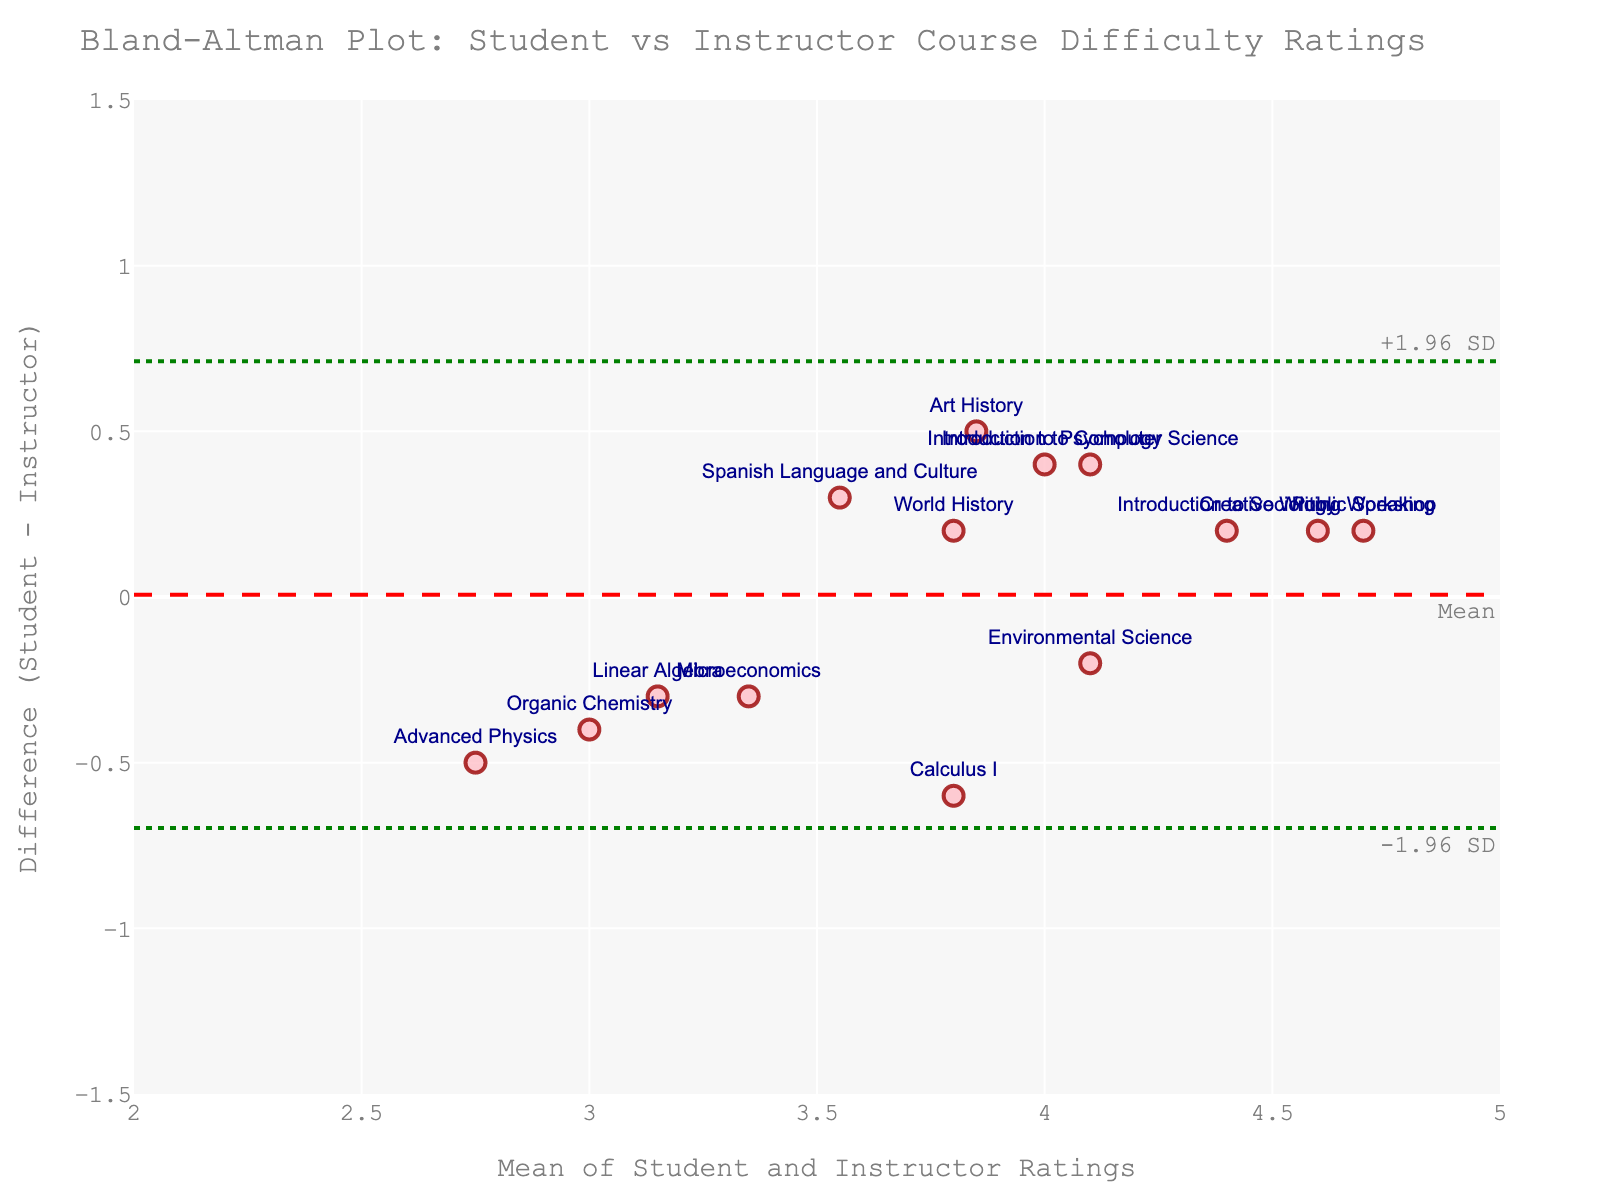What's the title of the plot? The plot has a clear title at the top which helps to identify what the data represents. Reading the header information, the title says "Bland-Altman Plot: Student vs Instructor Course Difficulty Ratings". This succinctly describes the focus of the analysis.
Answer: Bland-Altman Plot: Student vs Instructor Course Difficulty Ratings How many courses have been evaluated? By counting the number of markers representing the courses on the scatter plot, you can determine the number of evaluations included. There are 14 markers, each labeled with a course name.
Answer: 14 What do the x and y axes represent? The x-axis and the y-axis labels provide information about what is being plotted. The x-axis is labeled as "Mean of Student and Instructor Ratings", and the y-axis is labeled as "Difference (Student - Instructor)". These labels indicate the values being compared on each axis.
Answer: x-axis: Mean of Student and Instructor Ratings; y-axis: Difference (Student - Instructor) What is the overall mean difference in ratings between students and instructors? This can be found by looking at the dashed horizontal line labeled "Mean". It represents the average difference between student and instructor ratings. The mean difference is found at a particular point on the y-axis, which appears to be around 0.
Answer: Around 0 What are the limits of agreement? The horizontal dotted lines represent the limits of agreement. These are typically calculated as mean difference ± 1.96 times the standard deviation of the differences. Observing the dotted lines, one is labeled as "-1.96 SD" and another as "+1.96 SD". The values are found at approximately -0.8 and 0.8.
Answer: -0.8 and 0.8 Which course has the largest positive difference between student and instructor ratings? By examining the plot, we find the highest point along the positive y-axis away from the mean line. The course labeled "Art History" is situated at the largest positive difference.
Answer: Art History Which course has the largest negative difference between student and instructor ratings? To find the course with the largest negative difference, look at the lowest point on the negative y-axis. The course labeled "Introduction to Computer Science" has the largest negative difference.
Answer: Introduction to Computer Science What is the range of the mean ratings? The range of the x-axis shows the spread in the means of student and instructor ratings. Observing the x-axis labels, the range is approximately from 2 to 5.
Answer: 2 to 5 Is there any course where the student and instructor ratings almost agree? Look for data points (markers) that are close to the y=0 line, which indicates almost no difference between student and instructor ratings. The course "Creative Writing Workshop" appears very close to the zero difference line.
Answer: Creative Writing Workshop Do any courses fall outside the limits of agreement? Compare each marker's position with the horizontal lines representing the limits of agreement. No points fall outside the limits of agreement between -0.8 to 0.8, meaning all courses are within this range.
Answer: No 